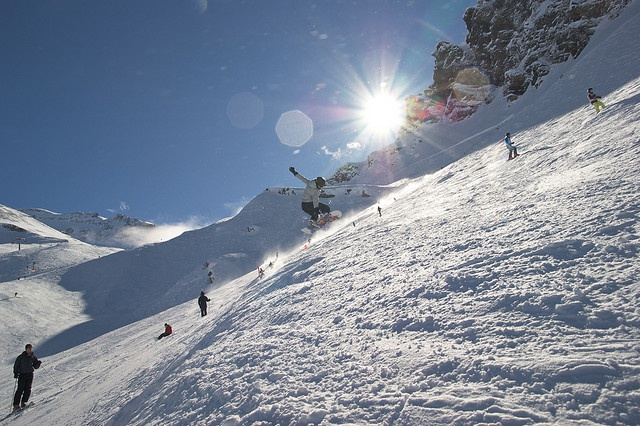Describe the objects in this image and their specific colors. I can see people in darkblue, black, gray, darkgray, and maroon tones, people in darkblue, gray, and black tones, snowboard in darkblue, gray, and darkgray tones, people in darkblue, gray, lightgray, black, and darkgray tones, and people in darkblue, gray, black, darkgreen, and olive tones in this image. 